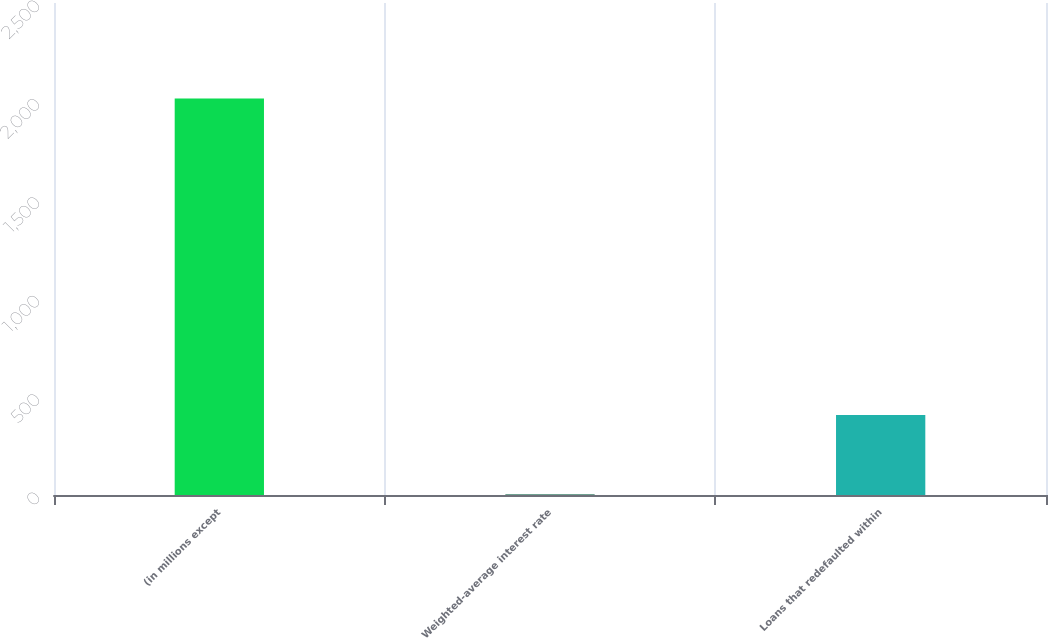Convert chart. <chart><loc_0><loc_0><loc_500><loc_500><bar_chart><fcel>(in millions except<fcel>Weighted-average interest rate<fcel>Loans that redefaulted within<nl><fcel>2015<fcel>4.4<fcel>406.52<nl></chart> 